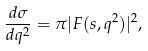Convert formula to latex. <formula><loc_0><loc_0><loc_500><loc_500>\frac { d \sigma } { d q ^ { 2 } } = \pi | F ( s , q ^ { 2 } ) | ^ { 2 } ,</formula> 